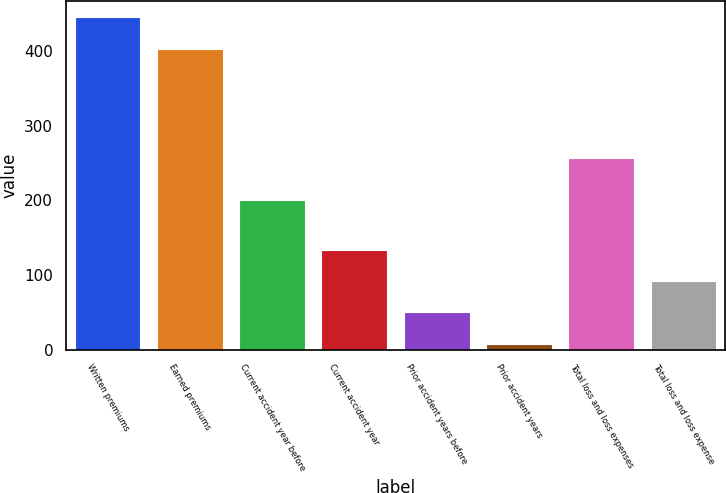Convert chart to OTSL. <chart><loc_0><loc_0><loc_500><loc_500><bar_chart><fcel>Written premiums<fcel>Earned premiums<fcel>Current accident year before<fcel>Current accident year<fcel>Prior accident years before<fcel>Prior accident years<fcel>Total loss and loss expenses<fcel>Total loss and loss expense<nl><fcel>445<fcel>403<fcel>201<fcel>134<fcel>50<fcel>8<fcel>257<fcel>92<nl></chart> 